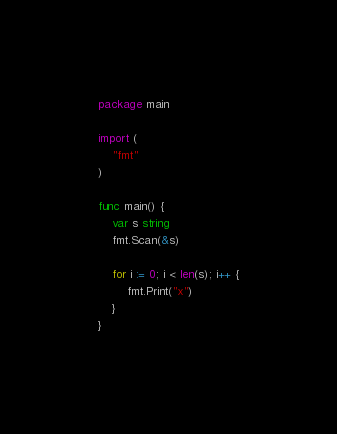<code> <loc_0><loc_0><loc_500><loc_500><_Go_>package main

import (
	"fmt"
)

func main() {
	var s string
	fmt.Scan(&s)

	for i := 0; i < len(s); i++ {
		fmt.Print("x")
	}
}
</code> 